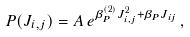<formula> <loc_0><loc_0><loc_500><loc_500>P ( J _ { i , j } ) = A \, e ^ { \beta ^ { ( 2 ) } _ { P } J ^ { 2 } _ { i , j } + \beta _ { P } J _ { i j } } \, ,</formula> 